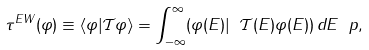Convert formula to latex. <formula><loc_0><loc_0><loc_500><loc_500>\tau ^ { E W } ( \varphi ) \equiv \langle \varphi | \mathcal { T } \varphi \rangle = \int _ { - \infty } ^ { \infty } ( \varphi ( E ) | \ \mathcal { T } ( E ) \varphi ( E ) ) \, d E \ p ,</formula> 